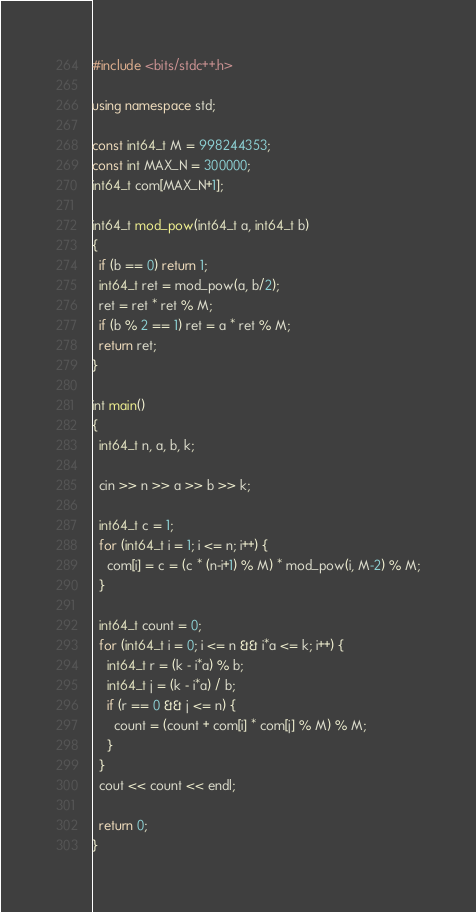<code> <loc_0><loc_0><loc_500><loc_500><_C++_>#include <bits/stdc++.h>

using namespace std;

const int64_t M = 998244353;
const int MAX_N = 300000;
int64_t com[MAX_N+1];

int64_t mod_pow(int64_t a, int64_t b)
{
  if (b == 0) return 1;
  int64_t ret = mod_pow(a, b/2);
  ret = ret * ret % M;
  if (b % 2 == 1) ret = a * ret % M;
  return ret;
}

int main()
{
  int64_t n, a, b, k;

  cin >> n >> a >> b >> k;

  int64_t c = 1;
  for (int64_t i = 1; i <= n; i++) {
    com[i] = c = (c * (n-i+1) % M) * mod_pow(i, M-2) % M;
  }

  int64_t count = 0;
  for (int64_t i = 0; i <= n && i*a <= k; i++) {
    int64_t r = (k - i*a) % b;
    int64_t j = (k - i*a) / b;
    if (r == 0 && j <= n) {
      count = (count + com[i] * com[j] % M) % M;
    }
  }
  cout << count << endl;

  return 0;
}
</code> 